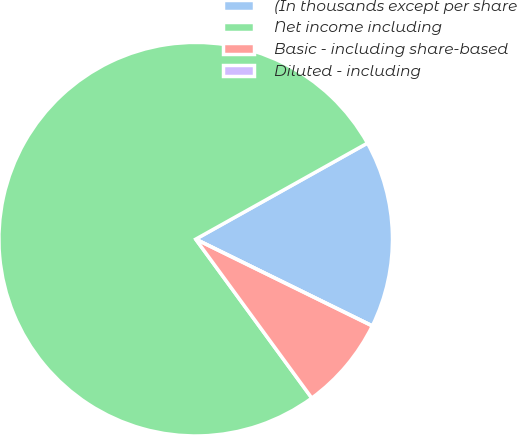Convert chart. <chart><loc_0><loc_0><loc_500><loc_500><pie_chart><fcel>(In thousands except per share<fcel>Net income including<fcel>Basic - including share-based<fcel>Diluted - including<nl><fcel>15.38%<fcel>76.92%<fcel>7.69%<fcel>0.0%<nl></chart> 